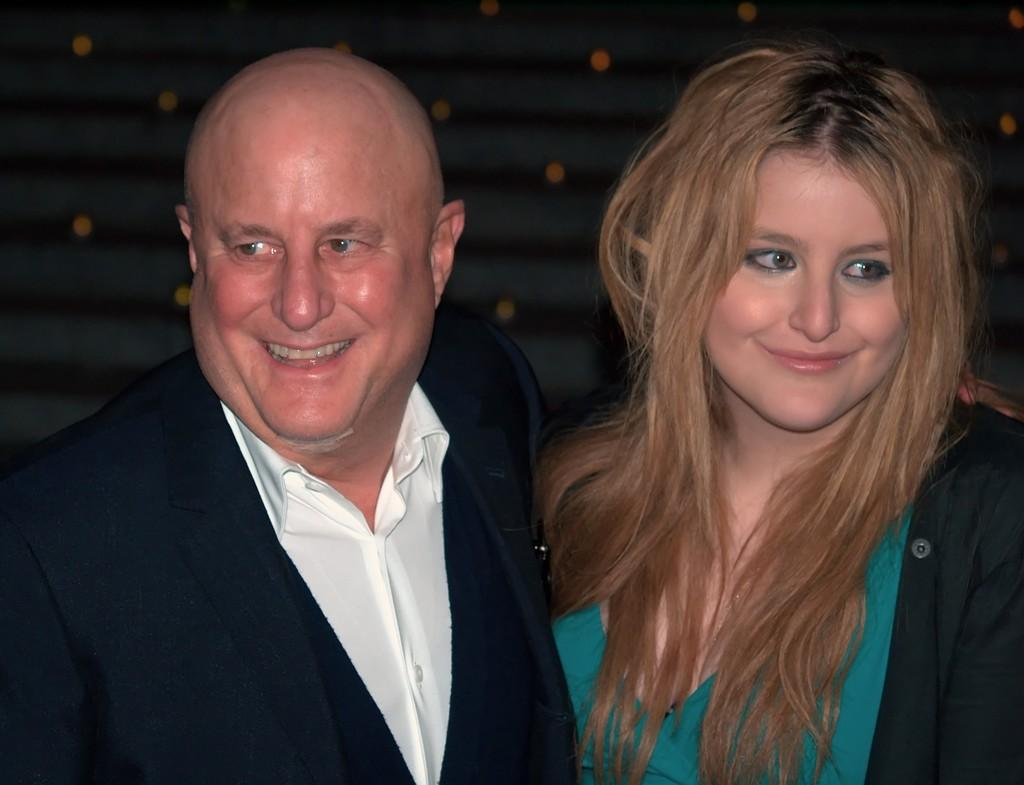How many people are in the image? There are persons in the image, but the exact number is not specified. What is the facial expression of the persons in the image? The persons in the image are smiling. Can you describe the background of the image? The background of the image is blurry. What type of texture can be seen on the pest in the image? There is no pest present in the image, so it is not possible to determine its texture. 